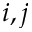<formula> <loc_0><loc_0><loc_500><loc_500>i , j</formula> 